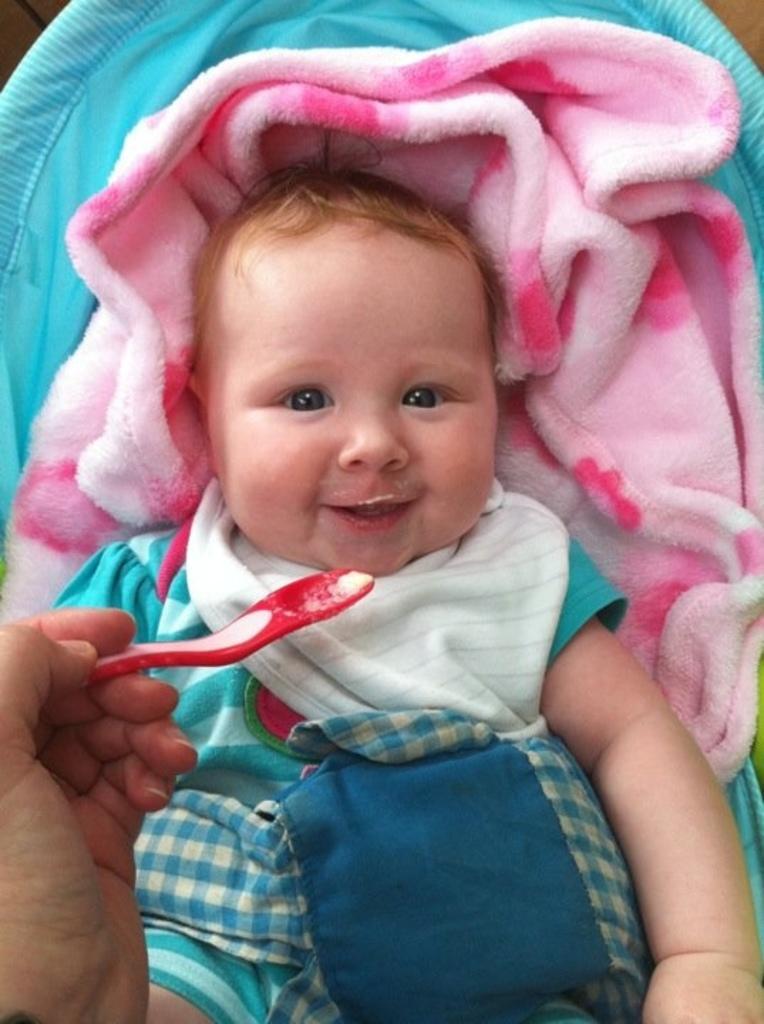How would you summarize this image in a sentence or two? Here in this picture we can see a baby with smiling. Baby is wearing a blue color dress. In this someone is feeding with the spoon. Under the baby there is a pink color cloth. 